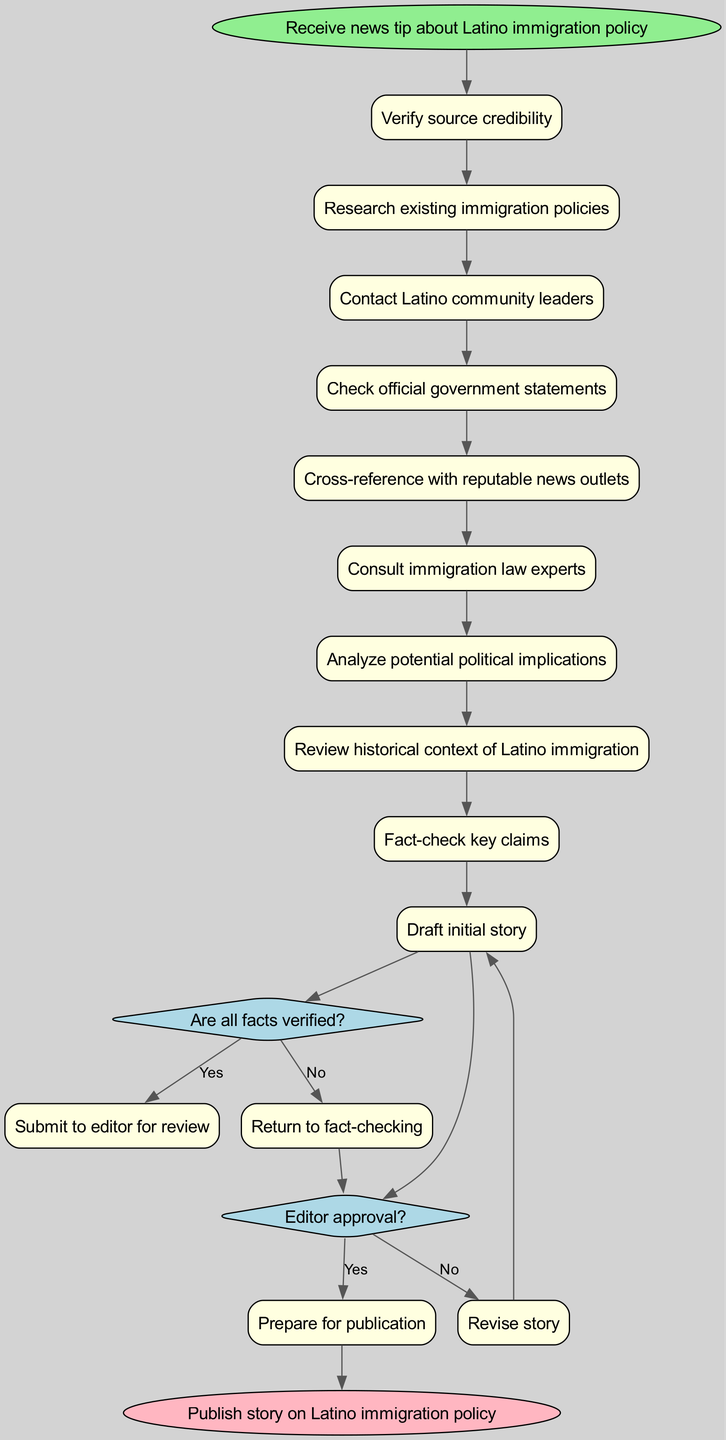What is the starting point of the activity diagram? The start node clearly states "Receive news tip about Latino immigration policy," which marks the beginning of the workflow.
Answer: Receive news tip about Latino immigration policy How many activities are present in the diagram? Counting the listed activities, there are a total of 10 activities displayed in the diagram.
Answer: 10 What is the first activity in the workflow? The first activity mentioned in the diagram after the start node is "Verify source credibility," indicating it is the initial step in the fact-checking process.
Answer: Verify source credibility What happens if the facts are not verified? The diagram clearly indicates that if the answer to the question "Are all facts verified?" is no, the flow returns to the "Fact-check key claims" activity for further review.
Answer: Return to fact-checking What is the end node of the activity diagram? The final step of the workflow is indicated by the end node, which states "Publish story on Latino immigration policy," marking the completion of the process.
Answer: Publish story on Latino immigration policy What question is posed to determine if the story is ready for submission? The decision node related to submission asks, "Editor approval?" which is essential to move forward in the workflow after fact-checking is complete.
Answer: Editor approval? If the editor does not approve the story, where does the flow lead? The flow for a "No" answer to the "Editor approval?" question leads to the "Revise story" activity, as indicated in the diagram, for necessary adjustments before resubmission.
Answer: Revise story What is the last activity before the end node? Before reaching the end node, the last activity illustrated in the diagram is "Prepare for publication," which is an essential step for finalizing the article.
Answer: Prepare for publication Where does the "Contact Latino community leaders" activity occur in the sequence? This activity appears in the middle of the workflow after "Research existing immigration policies" and before "Check official government statements," indicating its position among the other activities.
Answer: Middle of the sequence 